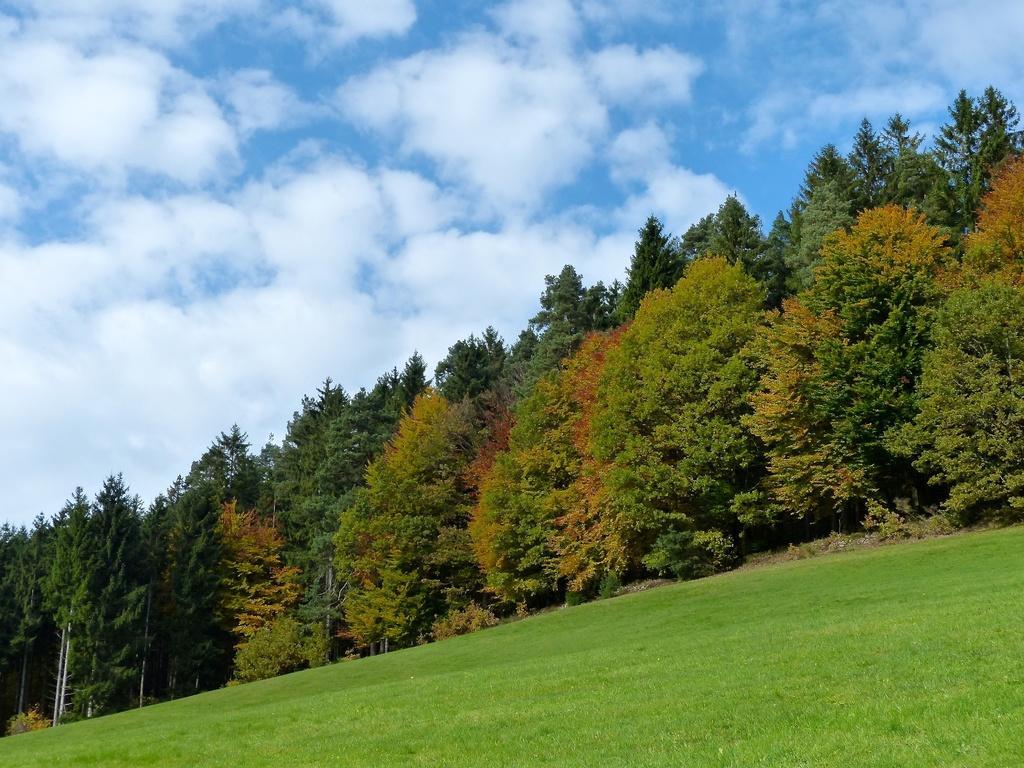Can you describe this image briefly? This image consists of many trees. At the bottom, there is green grass. At the top, there are clouds in the sky. 